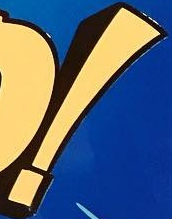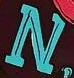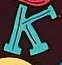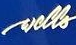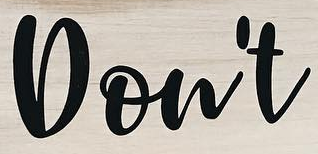Read the text from these images in sequence, separated by a semicolon. !; N; K; wells; Don't 